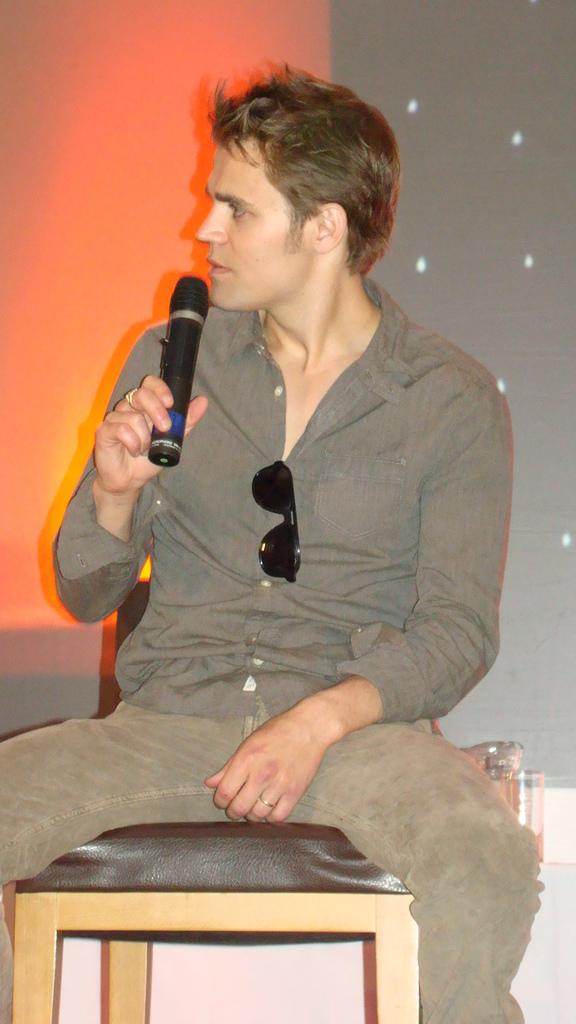Who is the main subject in the image? There is a man in the image. What is the man doing in the image? The man is sitting on a chair and holding a microphone, which suggests he might be talking. What can be seen in the background of the image? There is an orange and grey color in the background of the image. How many people are in the group that is pushing the soap in the image? There is no group or soap present in the image; it features a man sitting on a chair and holding a microphone. 